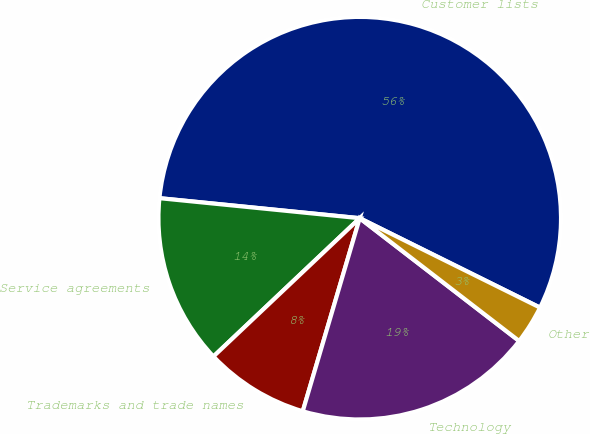Convert chart. <chart><loc_0><loc_0><loc_500><loc_500><pie_chart><fcel>Customer lists<fcel>Service agreements<fcel>Trademarks and trade names<fcel>Technology<fcel>Other<nl><fcel>55.74%<fcel>13.64%<fcel>8.38%<fcel>19.12%<fcel>3.12%<nl></chart> 